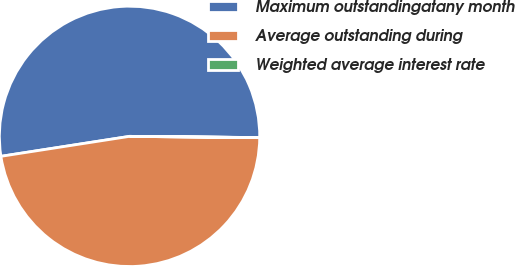Convert chart. <chart><loc_0><loc_0><loc_500><loc_500><pie_chart><fcel>Maximum outstandingatany month<fcel>Average outstanding during<fcel>Weighted average interest rate<nl><fcel>52.6%<fcel>47.39%<fcel>0.01%<nl></chart> 